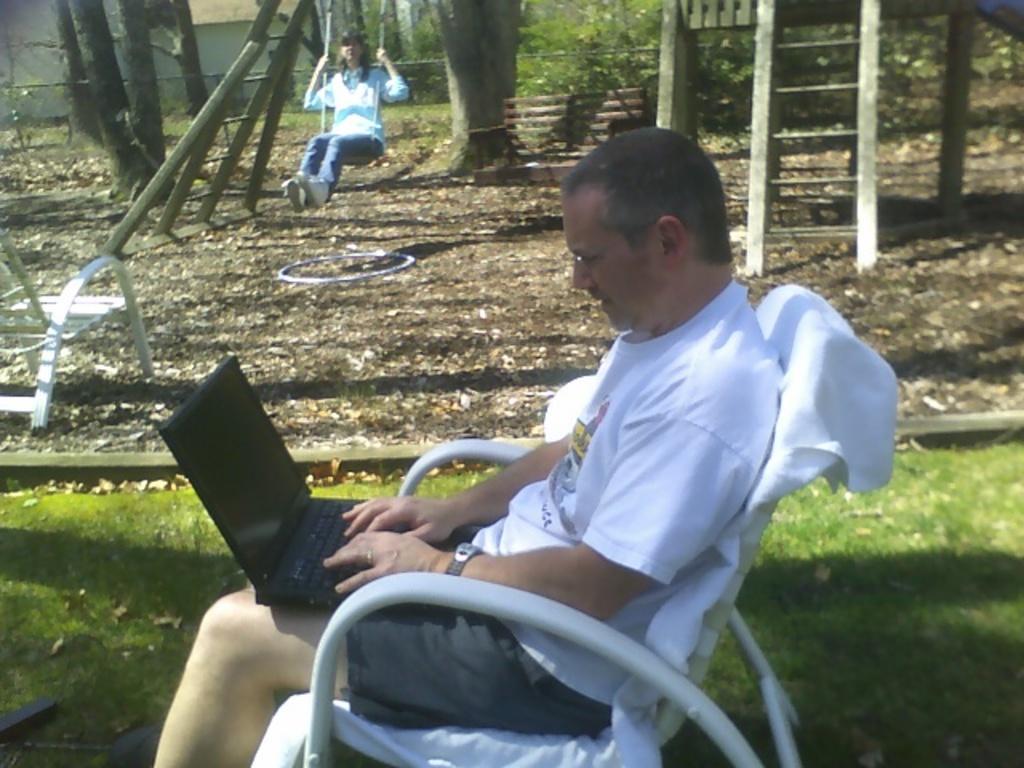Please provide a concise description of this image. In the middle of the image we can see a man, he is sitting on the chair, in front of him we can see a laptop, in the background we can see few trees and a woman, she is sitting on the swing. 